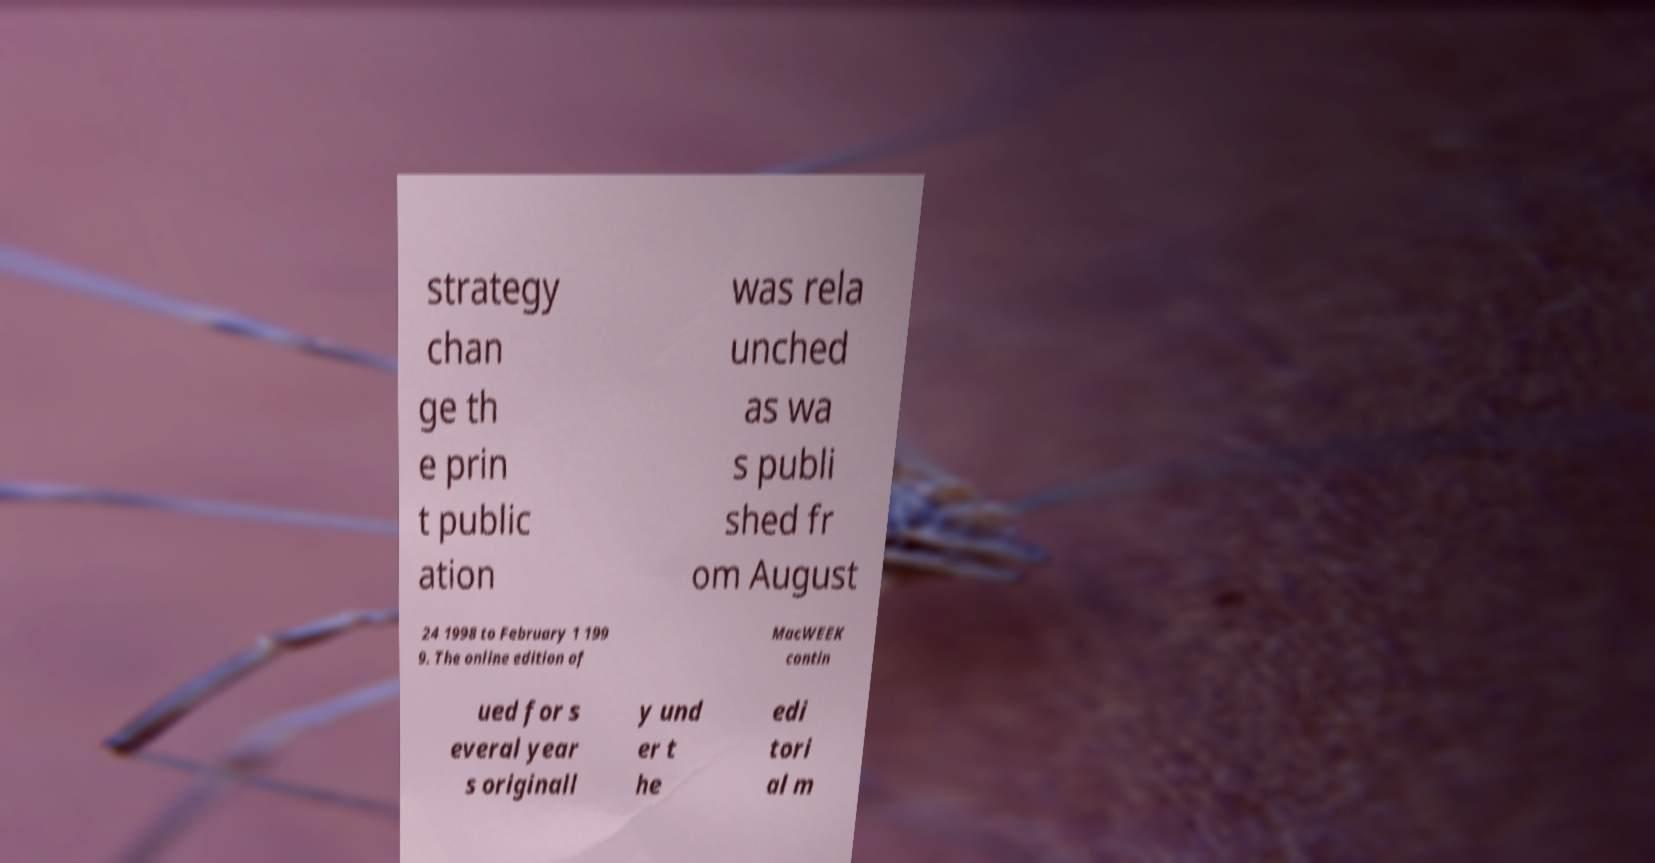Can you accurately transcribe the text from the provided image for me? strategy chan ge th e prin t public ation was rela unched as wa s publi shed fr om August 24 1998 to February 1 199 9. The online edition of MacWEEK contin ued for s everal year s originall y und er t he edi tori al m 